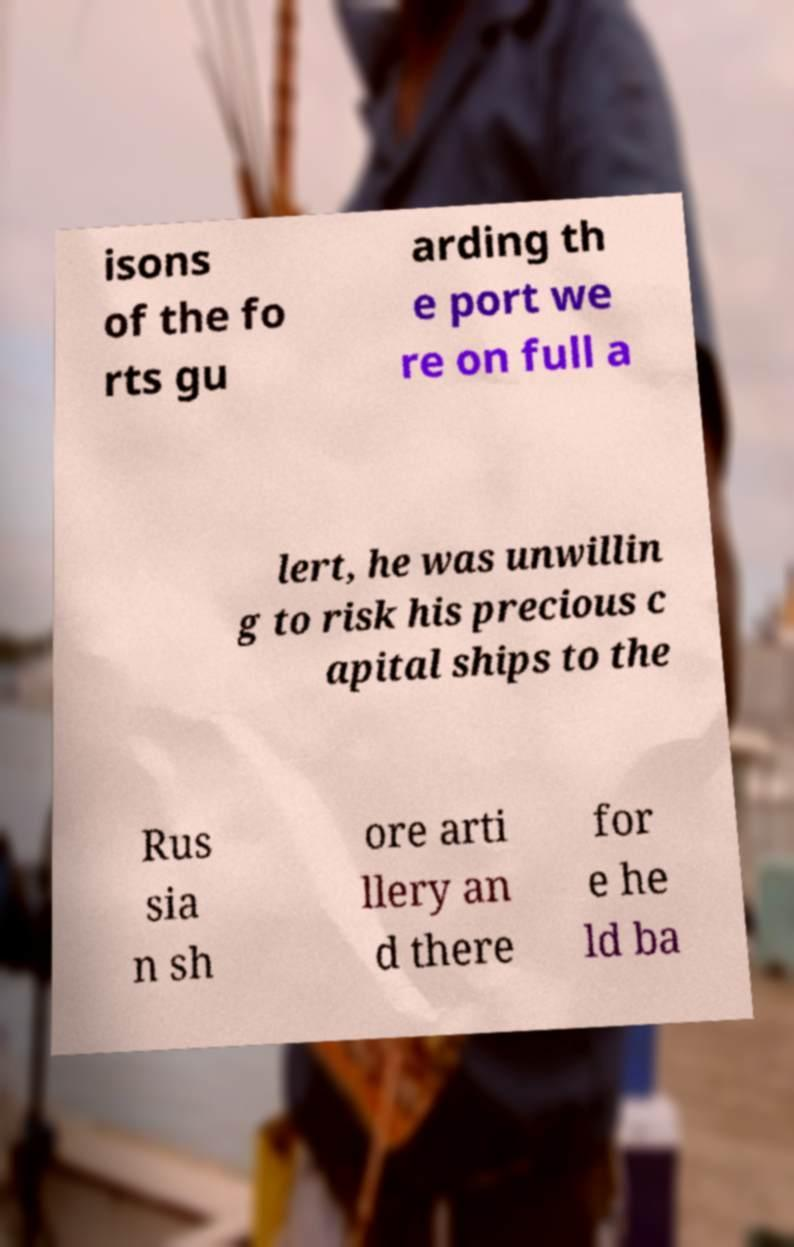Could you extract and type out the text from this image? isons of the fo rts gu arding th e port we re on full a lert, he was unwillin g to risk his precious c apital ships to the Rus sia n sh ore arti llery an d there for e he ld ba 